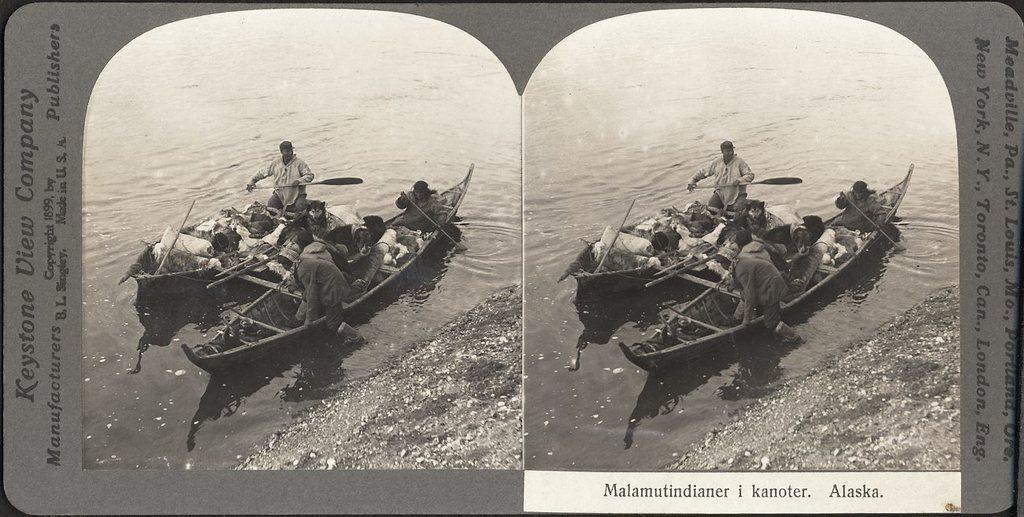Describe this image in one or two sentences. This is a collage image. I can see few people and objects on the boats, which are on the water. There are letters on the image. 